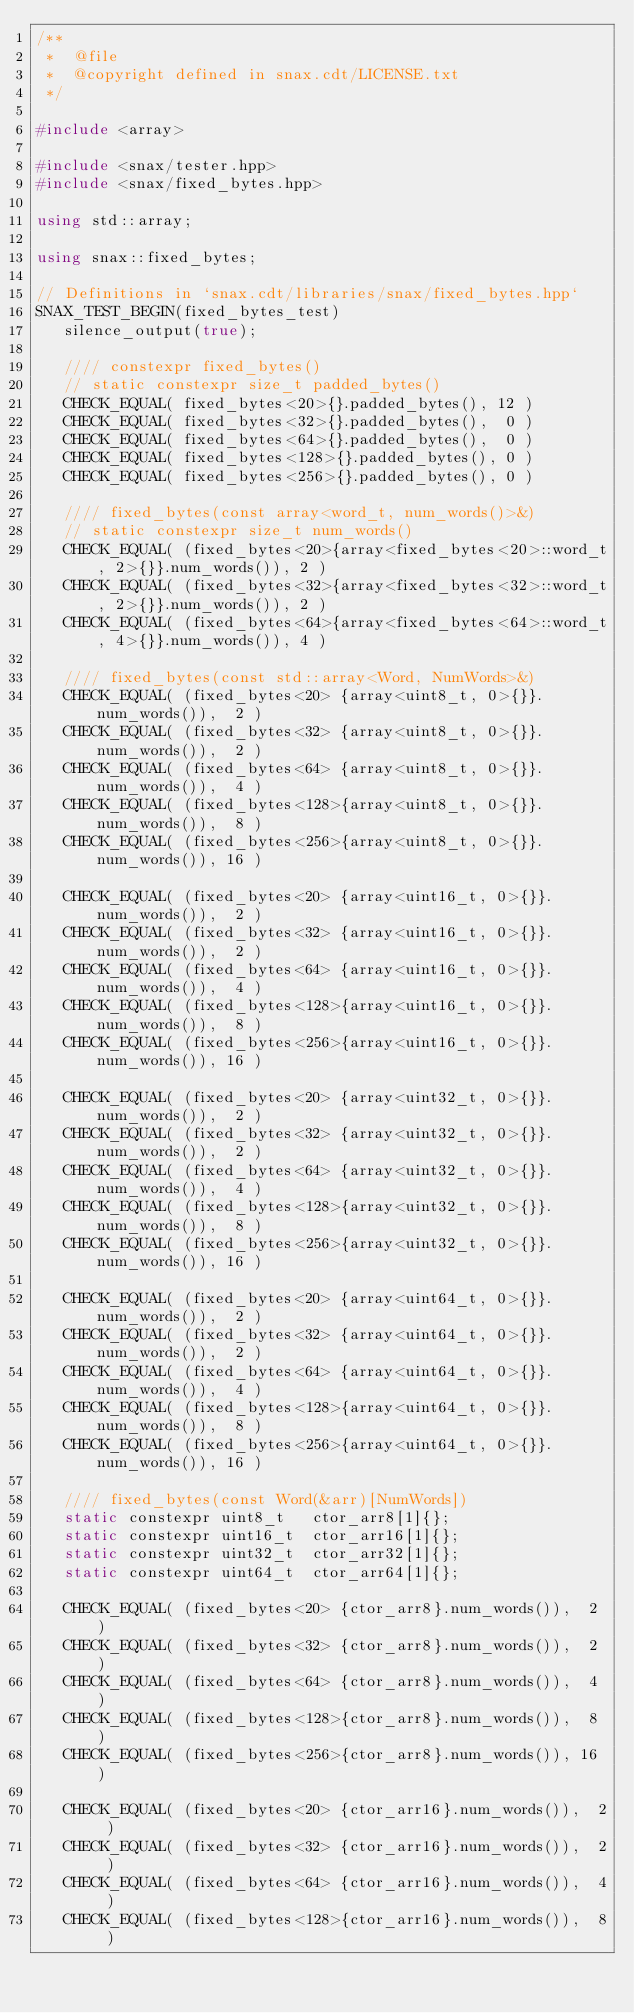Convert code to text. <code><loc_0><loc_0><loc_500><loc_500><_C++_>/**
 *  @file
 *  @copyright defined in snax.cdt/LICENSE.txt
 */

#include <array>

#include <snax/tester.hpp>
#include <snax/fixed_bytes.hpp>

using std::array;

using snax::fixed_bytes;

// Definitions in `snax.cdt/libraries/snax/fixed_bytes.hpp`
SNAX_TEST_BEGIN(fixed_bytes_test)
   silence_output(true);

   //// constexpr fixed_bytes()
   // static constexpr size_t padded_bytes()
   CHECK_EQUAL( fixed_bytes<20>{}.padded_bytes(), 12 )
   CHECK_EQUAL( fixed_bytes<32>{}.padded_bytes(),  0 )
   CHECK_EQUAL( fixed_bytes<64>{}.padded_bytes(),  0 )
   CHECK_EQUAL( fixed_bytes<128>{}.padded_bytes(), 0 )
   CHECK_EQUAL( fixed_bytes<256>{}.padded_bytes(), 0 )

   //// fixed_bytes(const array<word_t, num_words()>&)
   // static constexpr size_t num_words()
   CHECK_EQUAL( (fixed_bytes<20>{array<fixed_bytes<20>::word_t, 2>{}}.num_words()), 2 )
   CHECK_EQUAL( (fixed_bytes<32>{array<fixed_bytes<32>::word_t, 2>{}}.num_words()), 2 )
   CHECK_EQUAL( (fixed_bytes<64>{array<fixed_bytes<64>::word_t, 4>{}}.num_words()), 4 )

   //// fixed_bytes(const std::array<Word, NumWords>&)
   CHECK_EQUAL( (fixed_bytes<20> {array<uint8_t, 0>{}}.num_words()),  2 )
   CHECK_EQUAL( (fixed_bytes<32> {array<uint8_t, 0>{}}.num_words()),  2 )
   CHECK_EQUAL( (fixed_bytes<64> {array<uint8_t, 0>{}}.num_words()),  4 )
   CHECK_EQUAL( (fixed_bytes<128>{array<uint8_t, 0>{}}.num_words()),  8 )
   CHECK_EQUAL( (fixed_bytes<256>{array<uint8_t, 0>{}}.num_words()), 16 )

   CHECK_EQUAL( (fixed_bytes<20> {array<uint16_t, 0>{}}.num_words()),  2 )
   CHECK_EQUAL( (fixed_bytes<32> {array<uint16_t, 0>{}}.num_words()),  2 )
   CHECK_EQUAL( (fixed_bytes<64> {array<uint16_t, 0>{}}.num_words()),  4 )
   CHECK_EQUAL( (fixed_bytes<128>{array<uint16_t, 0>{}}.num_words()),  8 )
   CHECK_EQUAL( (fixed_bytes<256>{array<uint16_t, 0>{}}.num_words()), 16 )

   CHECK_EQUAL( (fixed_bytes<20> {array<uint32_t, 0>{}}.num_words()),  2 )
   CHECK_EQUAL( (fixed_bytes<32> {array<uint32_t, 0>{}}.num_words()),  2 )
   CHECK_EQUAL( (fixed_bytes<64> {array<uint32_t, 0>{}}.num_words()),  4 )
   CHECK_EQUAL( (fixed_bytes<128>{array<uint32_t, 0>{}}.num_words()),  8 )
   CHECK_EQUAL( (fixed_bytes<256>{array<uint32_t, 0>{}}.num_words()), 16 )

   CHECK_EQUAL( (fixed_bytes<20> {array<uint64_t, 0>{}}.num_words()),  2 )
   CHECK_EQUAL( (fixed_bytes<32> {array<uint64_t, 0>{}}.num_words()),  2 )
   CHECK_EQUAL( (fixed_bytes<64> {array<uint64_t, 0>{}}.num_words()),  4 )
   CHECK_EQUAL( (fixed_bytes<128>{array<uint64_t, 0>{}}.num_words()),  8 )
   CHECK_EQUAL( (fixed_bytes<256>{array<uint64_t, 0>{}}.num_words()), 16 )

   //// fixed_bytes(const Word(&arr)[NumWords])
   static constexpr uint8_t   ctor_arr8[1]{};
   static constexpr uint16_t  ctor_arr16[1]{};
   static constexpr uint32_t  ctor_arr32[1]{};
   static constexpr uint64_t  ctor_arr64[1]{};

   CHECK_EQUAL( (fixed_bytes<20> {ctor_arr8}.num_words()),  2 )
   CHECK_EQUAL( (fixed_bytes<32> {ctor_arr8}.num_words()),  2 )
   CHECK_EQUAL( (fixed_bytes<64> {ctor_arr8}.num_words()),  4 )
   CHECK_EQUAL( (fixed_bytes<128>{ctor_arr8}.num_words()),  8 )
   CHECK_EQUAL( (fixed_bytes<256>{ctor_arr8}.num_words()), 16 )

   CHECK_EQUAL( (fixed_bytes<20> {ctor_arr16}.num_words()),  2 )
   CHECK_EQUAL( (fixed_bytes<32> {ctor_arr16}.num_words()),  2 )
   CHECK_EQUAL( (fixed_bytes<64> {ctor_arr16}.num_words()),  4 )
   CHECK_EQUAL( (fixed_bytes<128>{ctor_arr16}.num_words()),  8 )</code> 